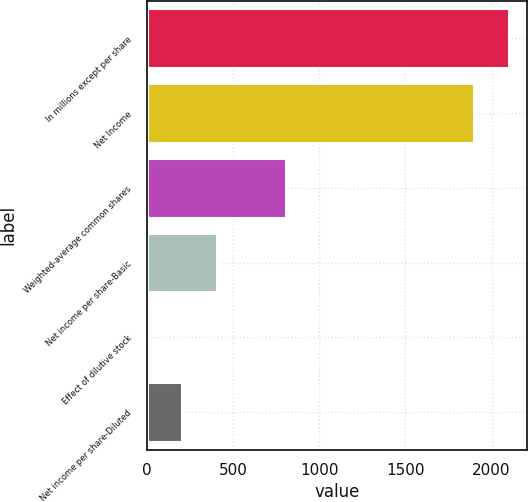Convert chart to OTSL. <chart><loc_0><loc_0><loc_500><loc_500><bar_chart><fcel>In millions except per share<fcel>Net Income<fcel>Weighted-average common shares<fcel>Net income per share-Basic<fcel>Effect of dilutive stock<fcel>Net income per share-Diluted<nl><fcel>2100.28<fcel>1899<fcel>807.32<fcel>404.76<fcel>2.2<fcel>203.48<nl></chart> 